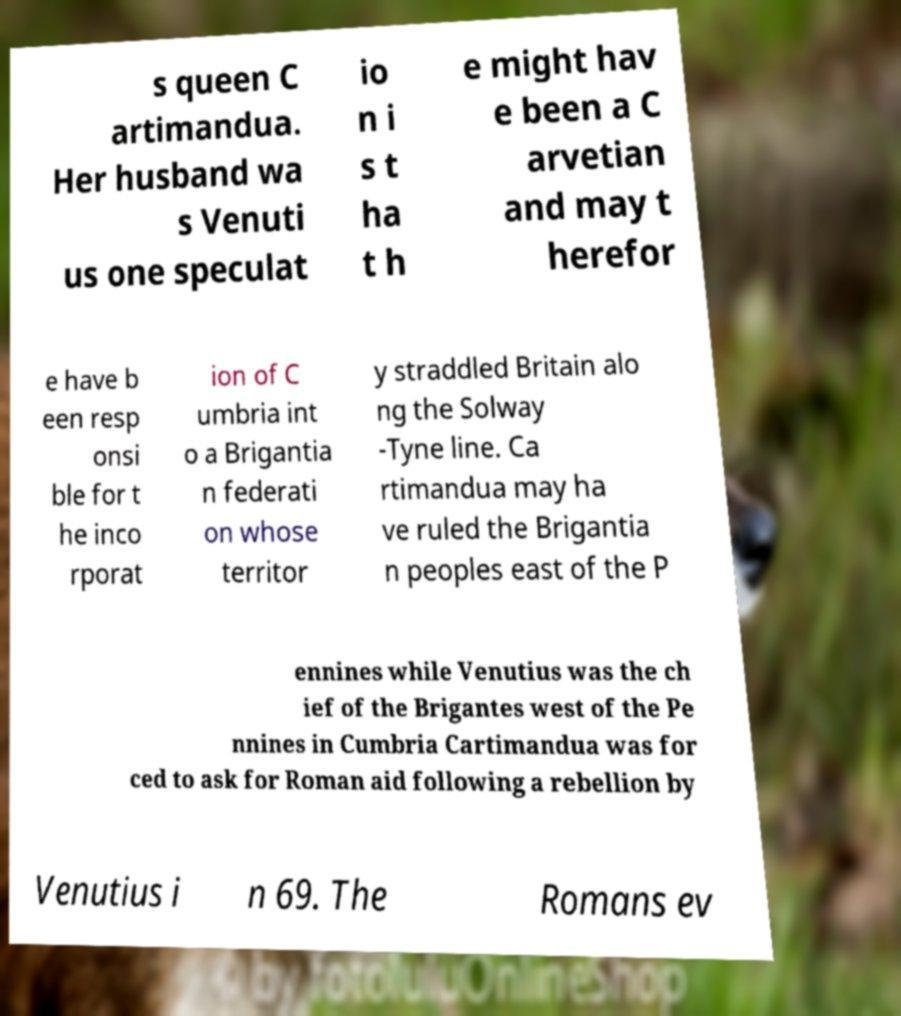Can you read and provide the text displayed in the image?This photo seems to have some interesting text. Can you extract and type it out for me? s queen C artimandua. Her husband wa s Venuti us one speculat io n i s t ha t h e might hav e been a C arvetian and may t herefor e have b een resp onsi ble for t he inco rporat ion of C umbria int o a Brigantia n federati on whose territor y straddled Britain alo ng the Solway -Tyne line. Ca rtimandua may ha ve ruled the Brigantia n peoples east of the P ennines while Venutius was the ch ief of the Brigantes west of the Pe nnines in Cumbria Cartimandua was for ced to ask for Roman aid following a rebellion by Venutius i n 69. The Romans ev 